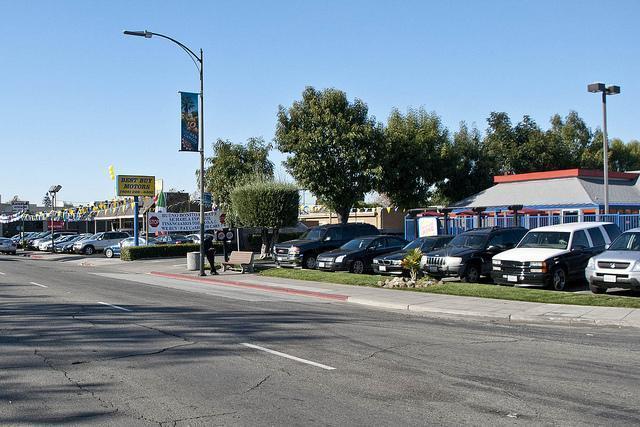How many cars are in the photo?
Give a very brief answer. 5. How many chair legs are touching only the orange surface of the floor?
Give a very brief answer. 0. 